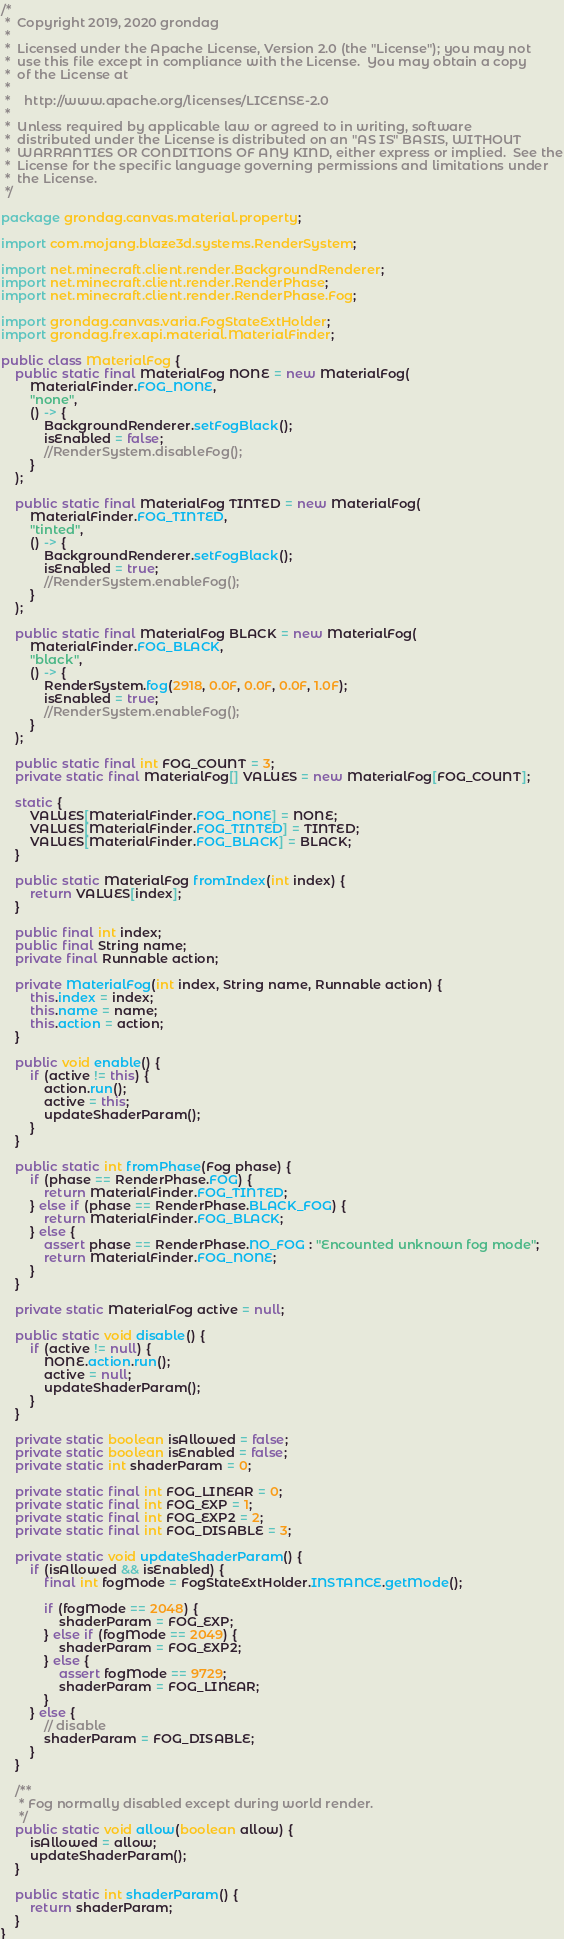Convert code to text. <code><loc_0><loc_0><loc_500><loc_500><_Java_>/*
 *  Copyright 2019, 2020 grondag
 *
 *  Licensed under the Apache License, Version 2.0 (the "License"); you may not
 *  use this file except in compliance with the License.  You may obtain a copy
 *  of the License at
 *
 *    http://www.apache.org/licenses/LICENSE-2.0
 *
 *  Unless required by applicable law or agreed to in writing, software
 *  distributed under the License is distributed on an "AS IS" BASIS, WITHOUT
 *  WARRANTIES OR CONDITIONS OF ANY KIND, either express or implied.  See the
 *  License for the specific language governing permissions and limitations under
 *  the License.
 */

package grondag.canvas.material.property;

import com.mojang.blaze3d.systems.RenderSystem;

import net.minecraft.client.render.BackgroundRenderer;
import net.minecraft.client.render.RenderPhase;
import net.minecraft.client.render.RenderPhase.Fog;

import grondag.canvas.varia.FogStateExtHolder;
import grondag.frex.api.material.MaterialFinder;

public class MaterialFog {
	public static final MaterialFog NONE = new MaterialFog(
		MaterialFinder.FOG_NONE,
		"none",
		() -> {
			BackgroundRenderer.setFogBlack();
			isEnabled = false;
			//RenderSystem.disableFog();
		}
	);

	public static final MaterialFog TINTED = new MaterialFog(
		MaterialFinder.FOG_TINTED,
		"tinted",
		() -> {
			BackgroundRenderer.setFogBlack();
			isEnabled = true;
			//RenderSystem.enableFog();
		}
	);

	public static final MaterialFog BLACK = new MaterialFog(
		MaterialFinder.FOG_BLACK,
		"black",
		() -> {
			RenderSystem.fog(2918, 0.0F, 0.0F, 0.0F, 1.0F);
			isEnabled = true;
			//RenderSystem.enableFog();
		}
	);

	public static final int FOG_COUNT = 3;
	private static final MaterialFog[] VALUES = new MaterialFog[FOG_COUNT];

	static {
		VALUES[MaterialFinder.FOG_NONE] = NONE;
		VALUES[MaterialFinder.FOG_TINTED] = TINTED;
		VALUES[MaterialFinder.FOG_BLACK] = BLACK;
	}

	public static MaterialFog fromIndex(int index) {
		return VALUES[index];
	}

	public final int index;
	public final String name;
	private final Runnable action;

	private MaterialFog(int index, String name, Runnable action) {
		this.index = index;
		this.name = name;
		this.action = action;
	}

	public void enable() {
		if (active != this) {
			action.run();
			active = this;
			updateShaderParam();
		}
	}

	public static int fromPhase(Fog phase) {
		if (phase == RenderPhase.FOG) {
			return MaterialFinder.FOG_TINTED;
		} else if (phase == RenderPhase.BLACK_FOG) {
			return MaterialFinder.FOG_BLACK;
		} else {
			assert phase == RenderPhase.NO_FOG : "Encounted unknown fog mode";
			return MaterialFinder.FOG_NONE;
		}
	}

	private static MaterialFog active = null;

	public static void disable() {
		if (active != null) {
			NONE.action.run();
			active = null;
			updateShaderParam();
		}
	}

	private static boolean isAllowed = false;
	private static boolean isEnabled = false;
	private static int shaderParam = 0;

	private static final int FOG_LINEAR = 0;
	private static final int FOG_EXP = 1;
	private static final int FOG_EXP2 = 2;
	private static final int FOG_DISABLE = 3;

	private static void updateShaderParam() {
		if (isAllowed && isEnabled) {
			final int fogMode = FogStateExtHolder.INSTANCE.getMode();

			if (fogMode == 2048) {
				shaderParam = FOG_EXP;
			} else if (fogMode == 2049) {
				shaderParam = FOG_EXP2;
			} else {
				assert fogMode == 9729;
				shaderParam = FOG_LINEAR;
			}
		} else {
			// disable
			shaderParam = FOG_DISABLE;
		}
	}

	/**
	 * Fog normally disabled except during world render.
	 */
	public static void allow(boolean allow) {
		isAllowed = allow;
		updateShaderParam();
	}

	public static int shaderParam() {
		return shaderParam;
	}
}
</code> 